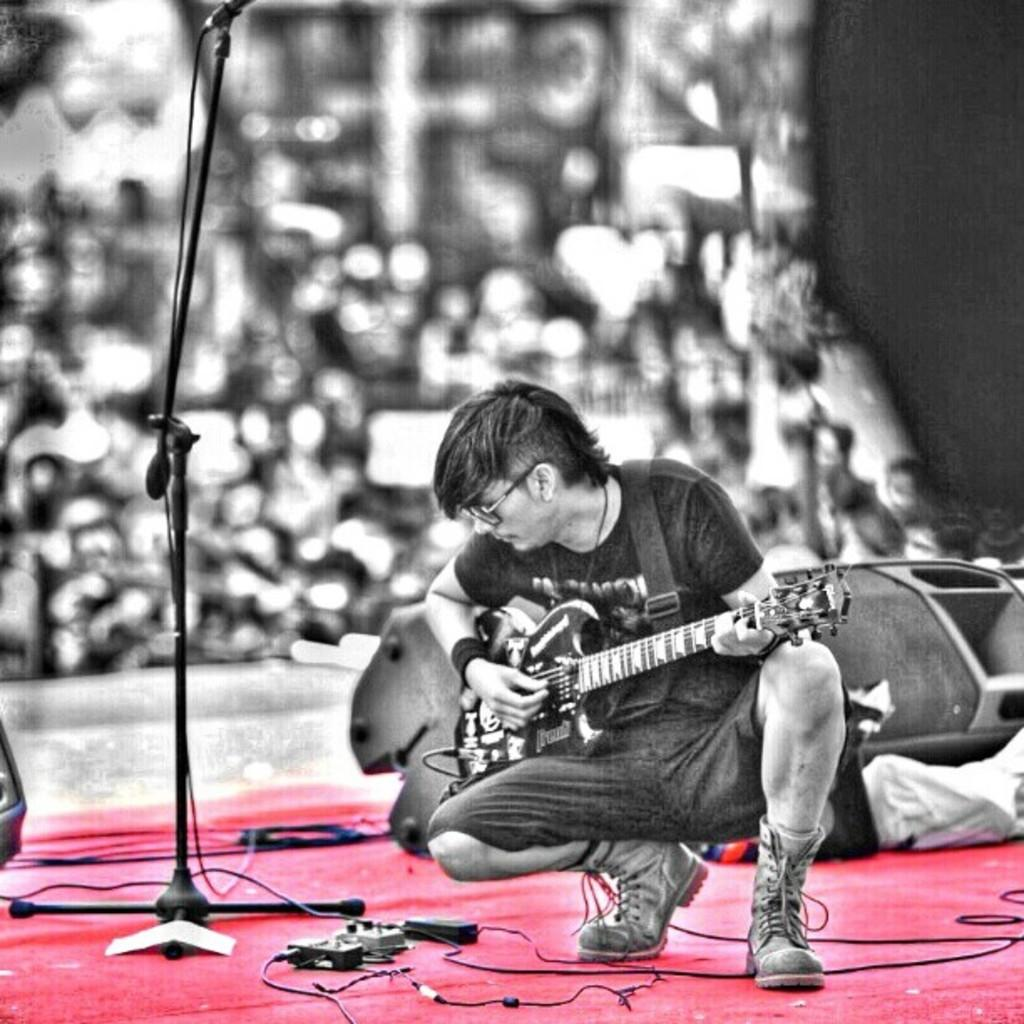What is the man in the image doing? The man is playing a guitar in the image. Where is the man located in the image? The man is on a stage in the image. What object is beside the man? There is a microphone beside the man in the image. Can you describe the audience in the image? There are people visible behind the man in the image. What type of fish can be seen swimming in the water behind the man? There is no water or fish visible in the image; the image only shows a man playing a guitar on a stage with a microphone and people behind him. 